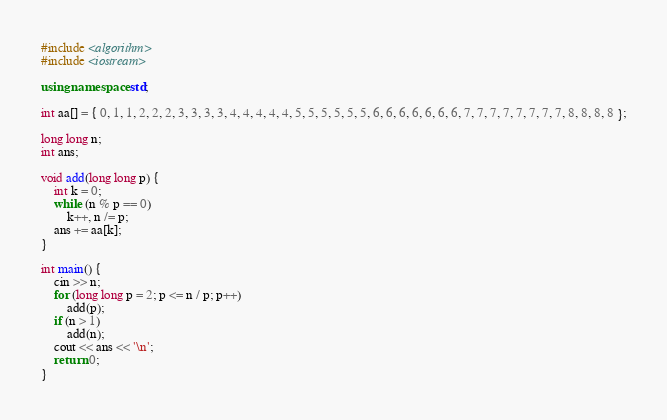Convert code to text. <code><loc_0><loc_0><loc_500><loc_500><_C++_>#include <algorithm>
#include <iostream>

using namespace std;

int aa[] = { 0, 1, 1, 2, 2, 2, 3, 3, 3, 3, 4, 4, 4, 4, 4, 5, 5, 5, 5, 5, 5, 6, 6, 6, 6, 6, 6, 6, 7, 7, 7, 7, 7, 7, 7, 7, 8, 8, 8, 8 };

long long n;
int ans;

void add(long long p) {
	int k = 0;
	while (n % p == 0)
		k++, n /= p;
	ans += aa[k];
}

int main() {
	cin >> n;
	for (long long p = 2; p <= n / p; p++)
		add(p);
	if (n > 1)
		add(n);
	cout << ans << '\n';
	return 0;
}
</code> 